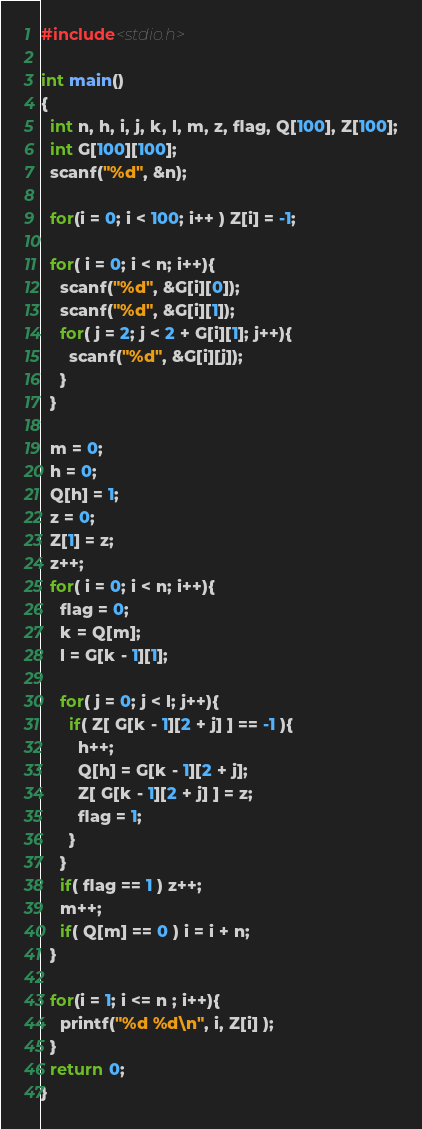<code> <loc_0><loc_0><loc_500><loc_500><_C_>#include<stdio.h>

int main()
{
  int n, h, i, j, k, l, m, z, flag, Q[100], Z[100];
  int G[100][100];
  scanf("%d", &n);
  
  for(i = 0; i < 100; i++ ) Z[i] = -1;
  
  for( i = 0; i < n; i++){
    scanf("%d", &G[i][0]);
    scanf("%d", &G[i][1]);
    for( j = 2; j < 2 + G[i][1]; j++){
      scanf("%d", &G[i][j]);
    }
  }
  
  m = 0; 
  h = 0; 
  Q[h] = 1;
  z = 0;
  Z[1] = z;
  z++;
  for( i = 0; i < n; i++){
    flag = 0;
    k = Q[m];
    l = G[k - 1][1];
    
    for( j = 0; j < l; j++){
      if( Z[ G[k - 1][2 + j] ] == -1 ){
        h++;
        Q[h] = G[k - 1][2 + j];
        Z[ G[k - 1][2 + j] ] = z;
        flag = 1;
      }
    }
    if( flag == 1 ) z++;
    m++;
    if( Q[m] == 0 ) i = i + n;
  }
  
  for(i = 1; i <= n ; i++){
    printf("%d %d\n", i, Z[i] );
  }
  return 0;
}</code> 